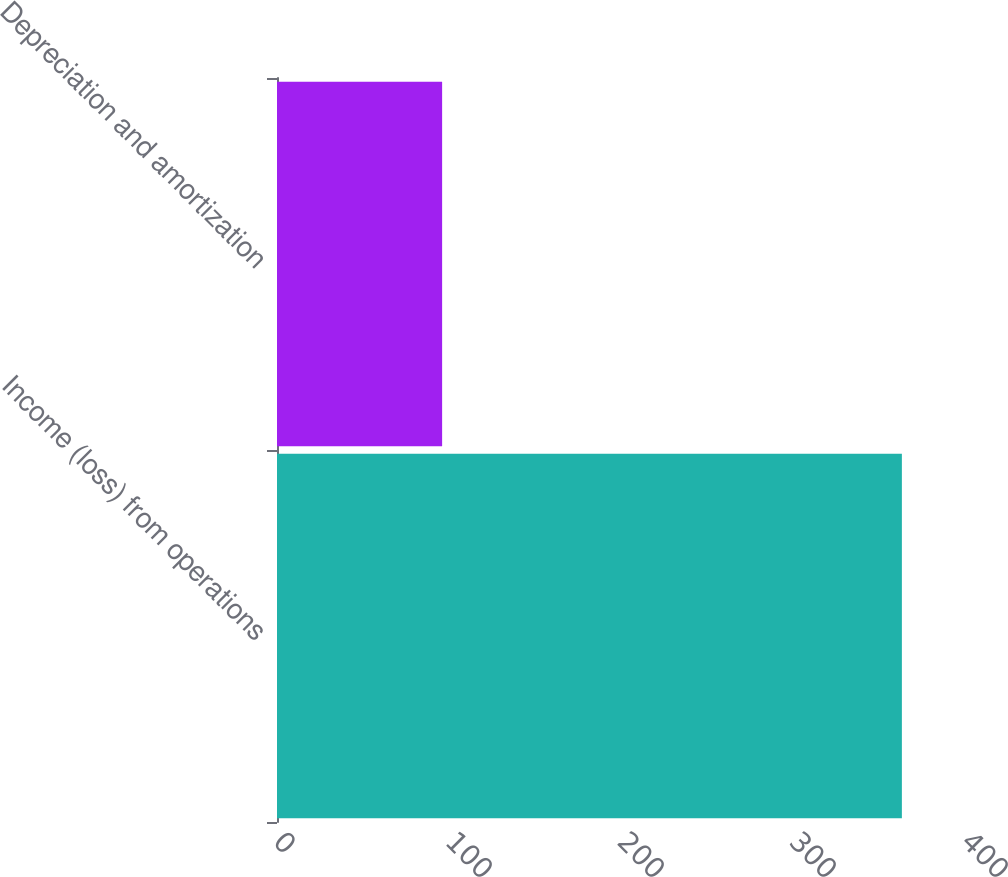Convert chart. <chart><loc_0><loc_0><loc_500><loc_500><bar_chart><fcel>Income (loss) from operations<fcel>Depreciation and amortization<nl><fcel>363.3<fcel>96<nl></chart> 